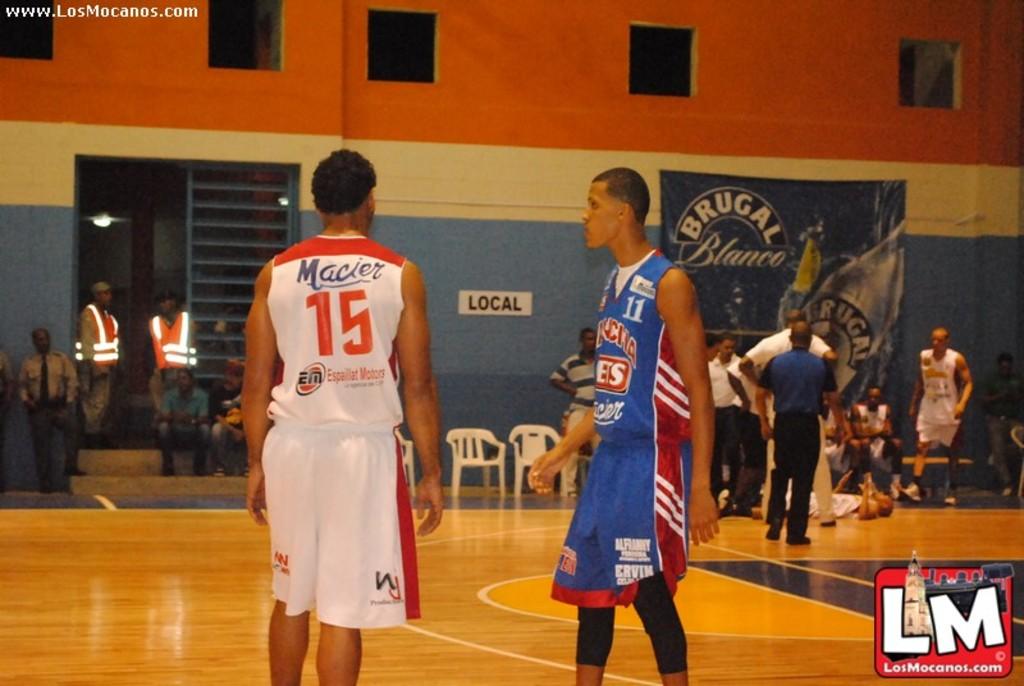White is the player in whites jersey number?
Make the answer very short. 15. White is the player in blue jersey number?
Your answer should be compact. 11. 